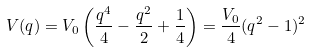Convert formula to latex. <formula><loc_0><loc_0><loc_500><loc_500>V ( q ) = V _ { 0 } \left ( \frac { q ^ { 4 } } { 4 } - \frac { q ^ { 2 } } { 2 } + \frac { 1 } { 4 } \right ) = \frac { V _ { 0 } } { 4 } ( q ^ { 2 } - 1 ) ^ { 2 }</formula> 